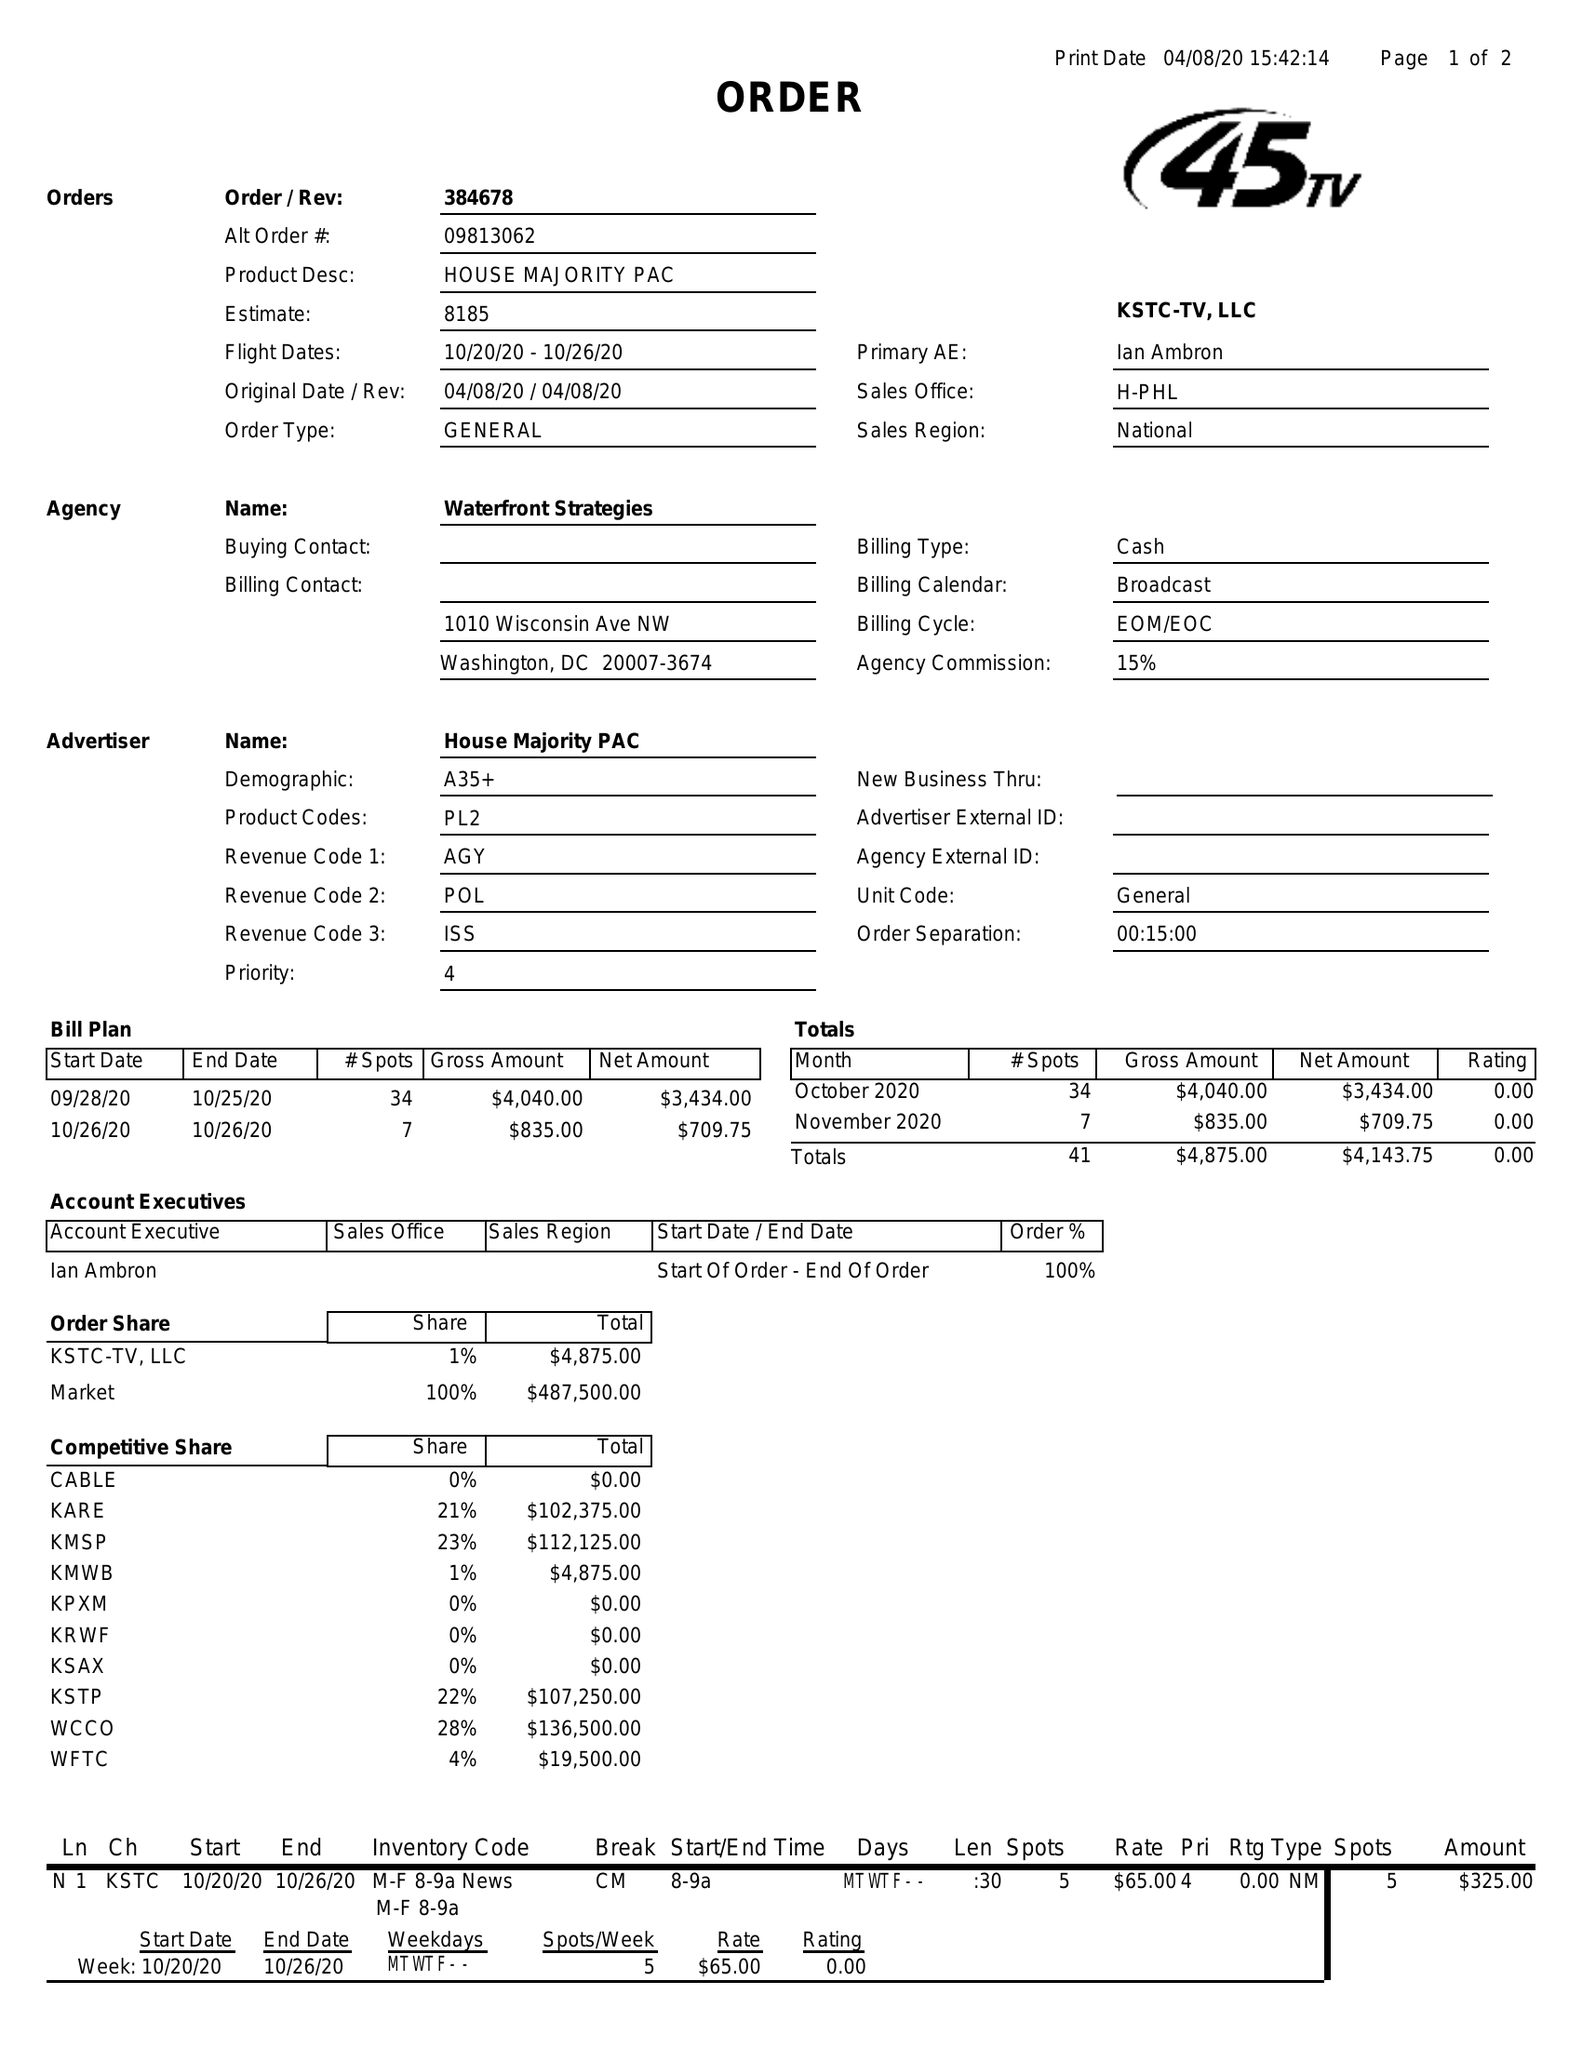What is the value for the flight_to?
Answer the question using a single word or phrase. 10/26/20 